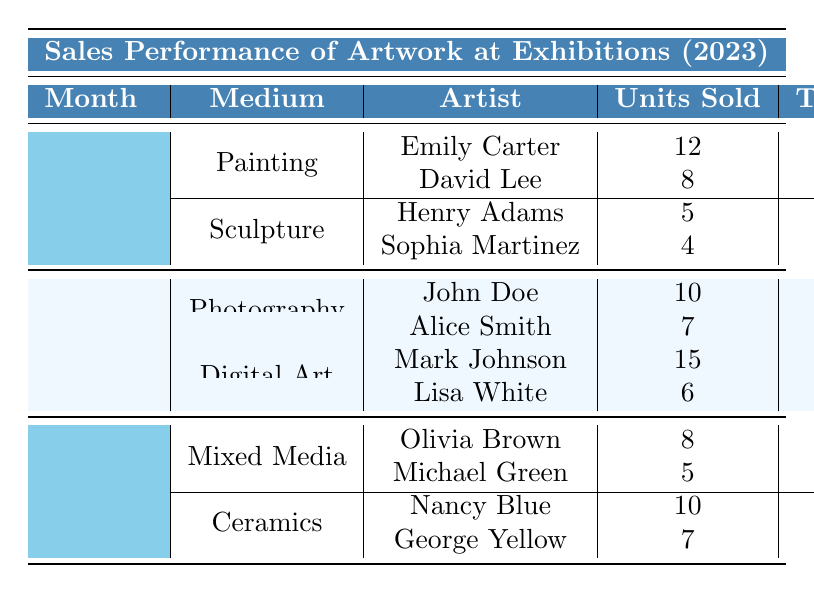What is the total revenue generated by Emily Carter in January? In January, Emily Carter sold 12 units of her artwork for a total revenue of $24,000. This value can be directly retrieved from the table under the January and Painting sections.
Answer: $24,000 How many units of Sculpture were sold in January? The total units sold for Sculpture in January can be calculated by adding the units sold by Henry Adams (5) and Sophia Martinez (4), which equals 5 + 4 = 9.
Answer: 9 Who sold more units in February, John Doe or Alice Smith? In February, John Doe sold 10 units while Alice Smith sold 7 units. Therefore, John Doe sold more units than Alice Smith.
Answer: John Doe What was the average price for mixed media art sold by Olivia Brown in March? Olivia Brown sold 8 units of mixed media art for an average price of $4,000, which is directly listed in the table under the March and Mixed Media sections.
Answer: $4,000 What was the total revenue generated from sculptures in January? The total revenue from sculptures can be found by adding the revenues from Henry Adams ($25,000) and Sophia Martinez ($16,000), resulting in $25,000 + $16,000 = $41,000.
Answer: $41,000 Which artist had the highest average price for artwork sold in January? From the table, Henry Adams sold sculpture at an average price of $5,000, which is higher than any other artist's average prices listed in January. Therefore, he had the highest average price.
Answer: Henry Adams Did any artist sell more than 10 units across the exhibitions in the first three months? Checking the data, Emily Carter sold 12 units in January, which is greater than 10. Thus, at least one artist did sell more than 10 units.
Answer: Yes What is the total number of units sold by Lisa White in February? In February, Lisa White sold 6 units, which can be found directly in the table under the February and Digital Art sections.
Answer: 6 Calculate the average number of units sold per artist in January. In January, 4 artists collectively sold 12 + 8 + 5 + 4 = 29 units total. There are 4 artists, so the average is 29 / 4 = 7.25.
Answer: 7.25 If Nancy Blue and George Yellow's total units sold in March are combined, how many units is that? Nancy Blue sold 10 units and George Yellow sold 7 units in March. Adding these amounts gives 10 + 7 = 17 units sold combined.
Answer: 17 